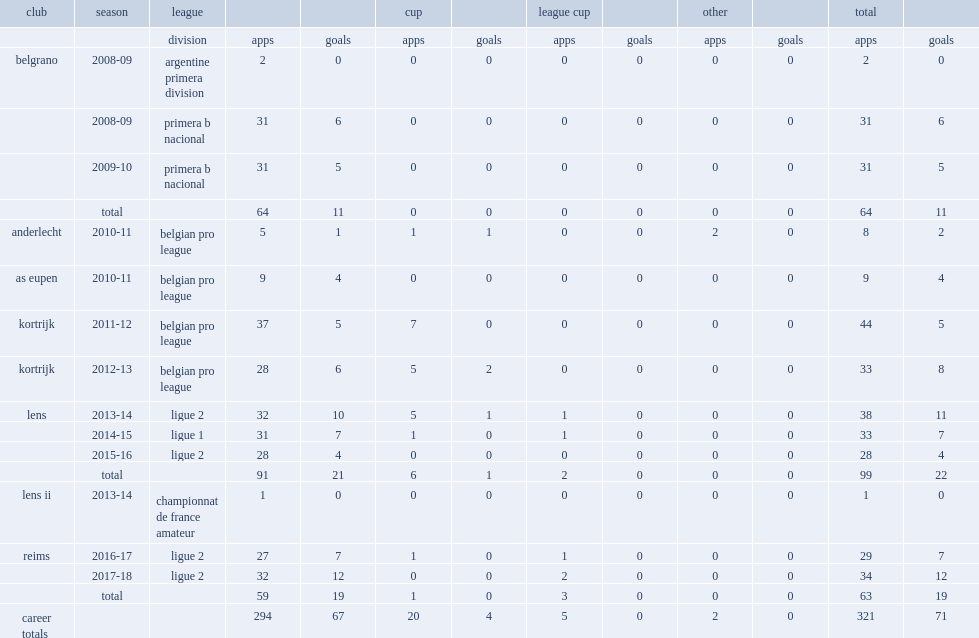In the 2015-16 season, which league did pablo chavarria play for lens in? Ligue 2. 